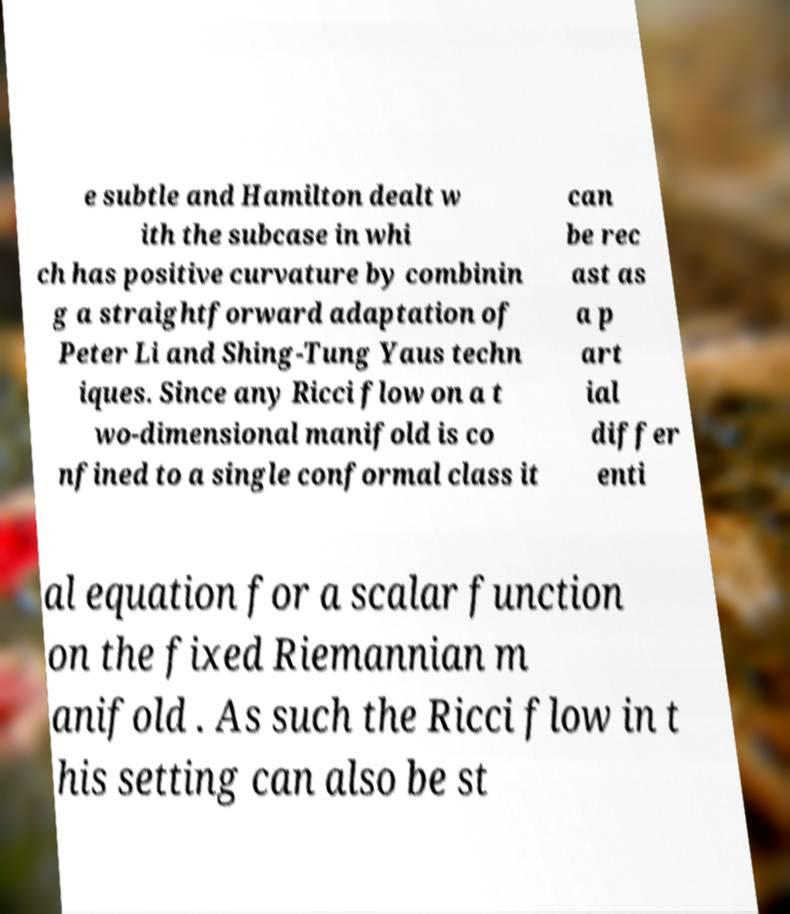Can you accurately transcribe the text from the provided image for me? e subtle and Hamilton dealt w ith the subcase in whi ch has positive curvature by combinin g a straightforward adaptation of Peter Li and Shing-Tung Yaus techn iques. Since any Ricci flow on a t wo-dimensional manifold is co nfined to a single conformal class it can be rec ast as a p art ial differ enti al equation for a scalar function on the fixed Riemannian m anifold . As such the Ricci flow in t his setting can also be st 